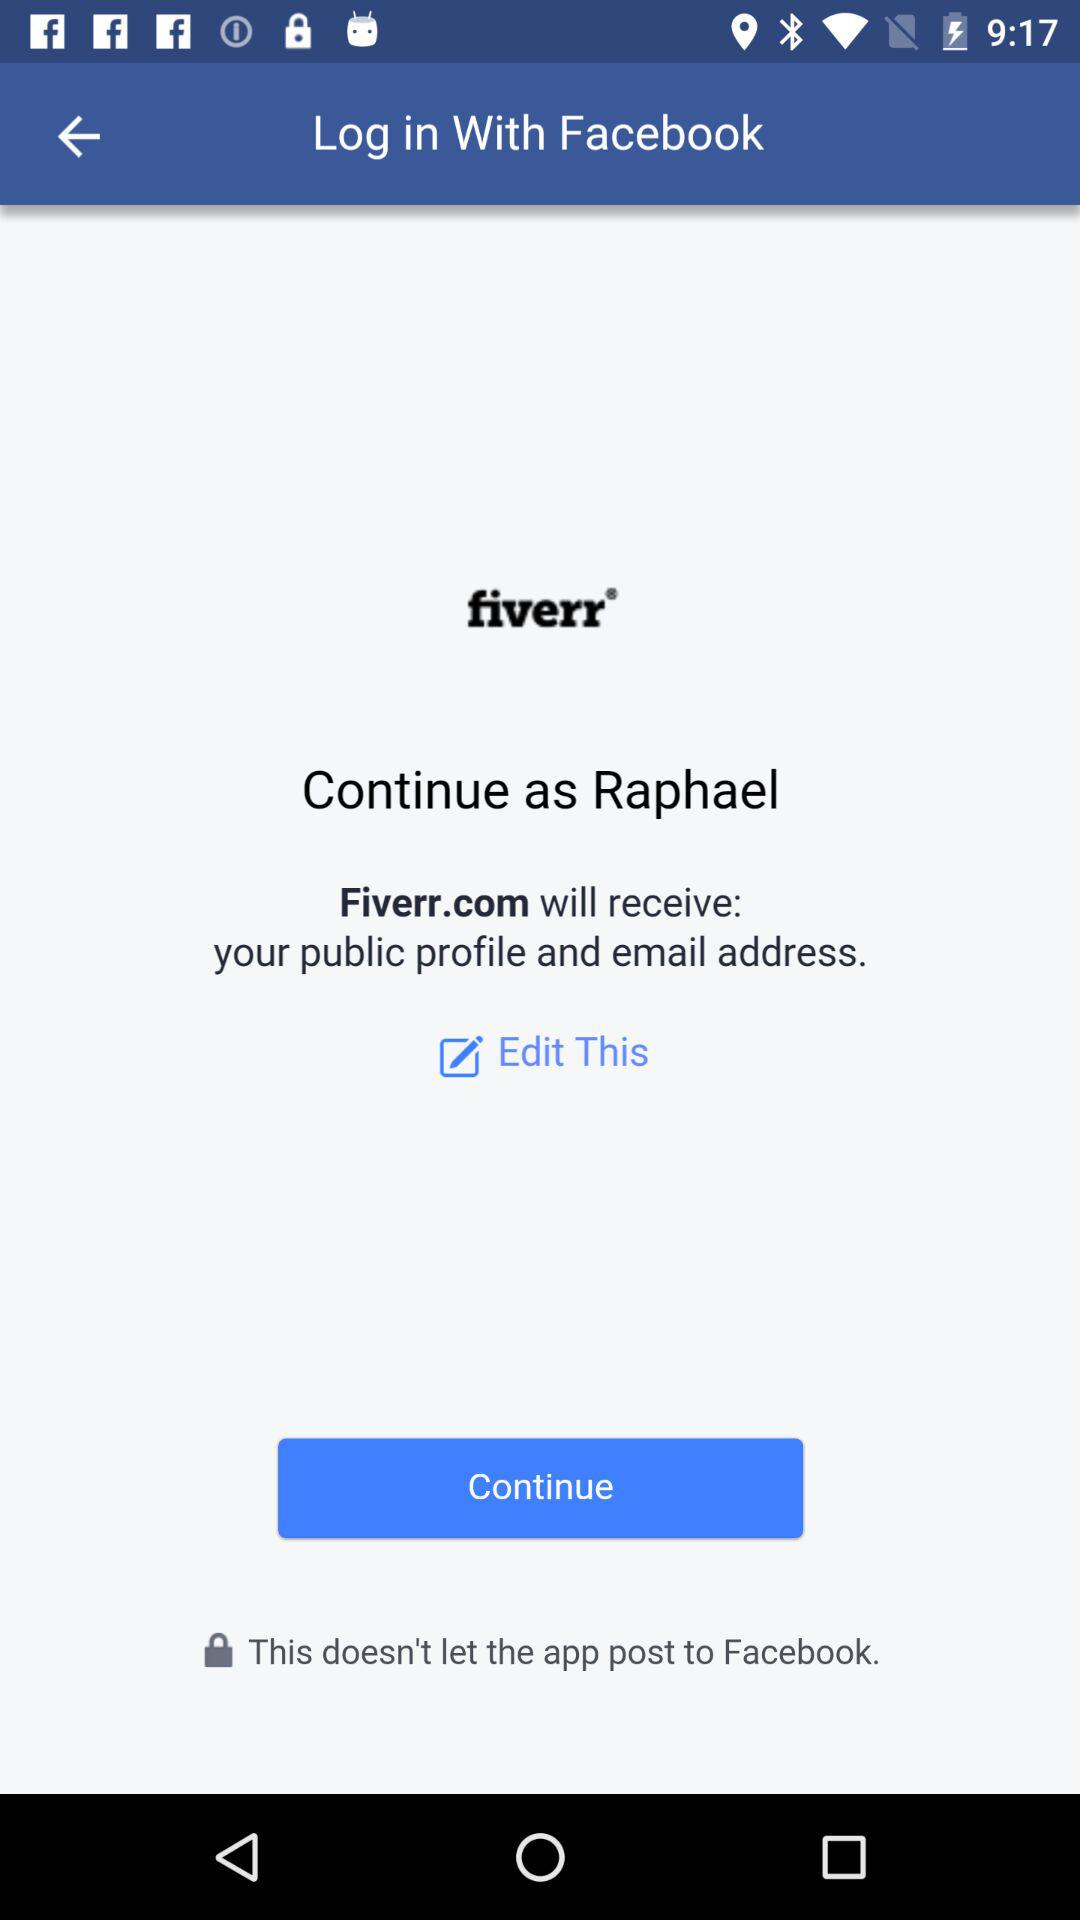What is the user name? The user name is Raphael. 